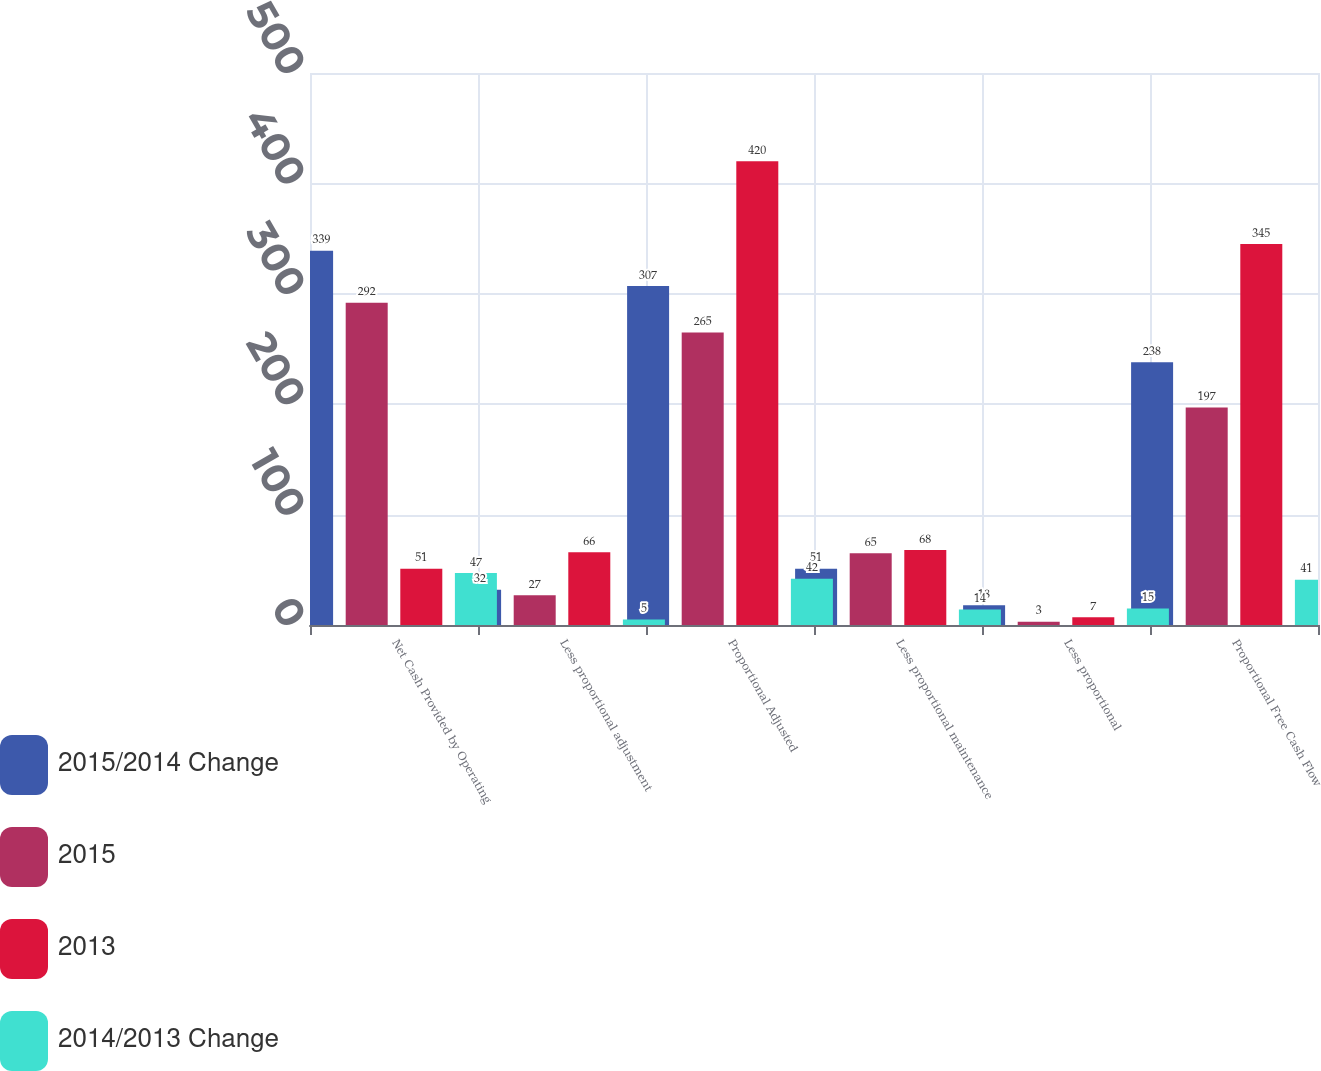Convert chart to OTSL. <chart><loc_0><loc_0><loc_500><loc_500><stacked_bar_chart><ecel><fcel>Net Cash Provided by Operating<fcel>Less proportional adjustment<fcel>Proportional Adjusted<fcel>Less proportional maintenance<fcel>Less proportional<fcel>Proportional Free Cash Flow<nl><fcel>2015/2014 Change<fcel>339<fcel>32<fcel>307<fcel>51<fcel>18<fcel>238<nl><fcel>2015<fcel>292<fcel>27<fcel>265<fcel>65<fcel>3<fcel>197<nl><fcel>2013<fcel>51<fcel>66<fcel>420<fcel>68<fcel>7<fcel>345<nl><fcel>2014/2013 Change<fcel>47<fcel>5<fcel>42<fcel>14<fcel>15<fcel>41<nl></chart> 